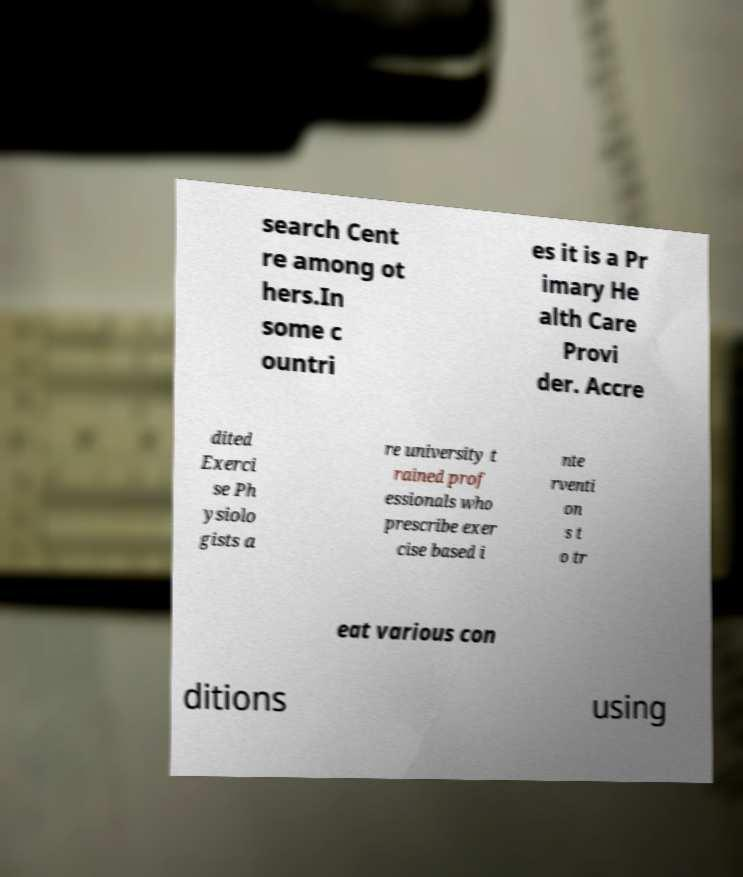Can you accurately transcribe the text from the provided image for me? search Cent re among ot hers.In some c ountri es it is a Pr imary He alth Care Provi der. Accre dited Exerci se Ph ysiolo gists a re university t rained prof essionals who prescribe exer cise based i nte rventi on s t o tr eat various con ditions using 